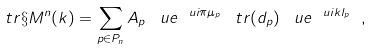<formula> <loc_0><loc_0><loc_500><loc_500>\ t r \S M ^ { n } ( k ) = \sum _ { p \in P _ { n } } A _ { p } \, \ u e ^ { \ u i \pi \mu _ { p } } \, \ t r ( d _ { p } ) \, \ u e ^ { \ u i k l _ { p } } \ ,</formula> 